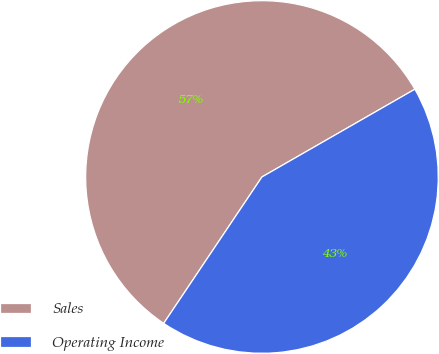<chart> <loc_0><loc_0><loc_500><loc_500><pie_chart><fcel>Sales<fcel>Operating Income<nl><fcel>57.3%<fcel>42.7%<nl></chart> 